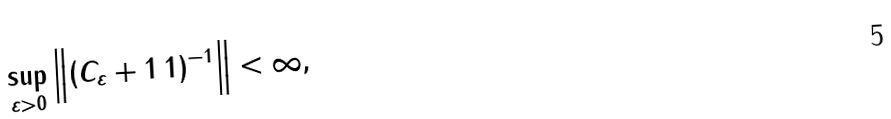Convert formula to latex. <formula><loc_0><loc_0><loc_500><loc_500>\sup _ { \varepsilon > 0 } \left \| \left ( C _ { \varepsilon } + 1 \, 1 \right ) ^ { - 1 } \right \| < \infty ,</formula> 